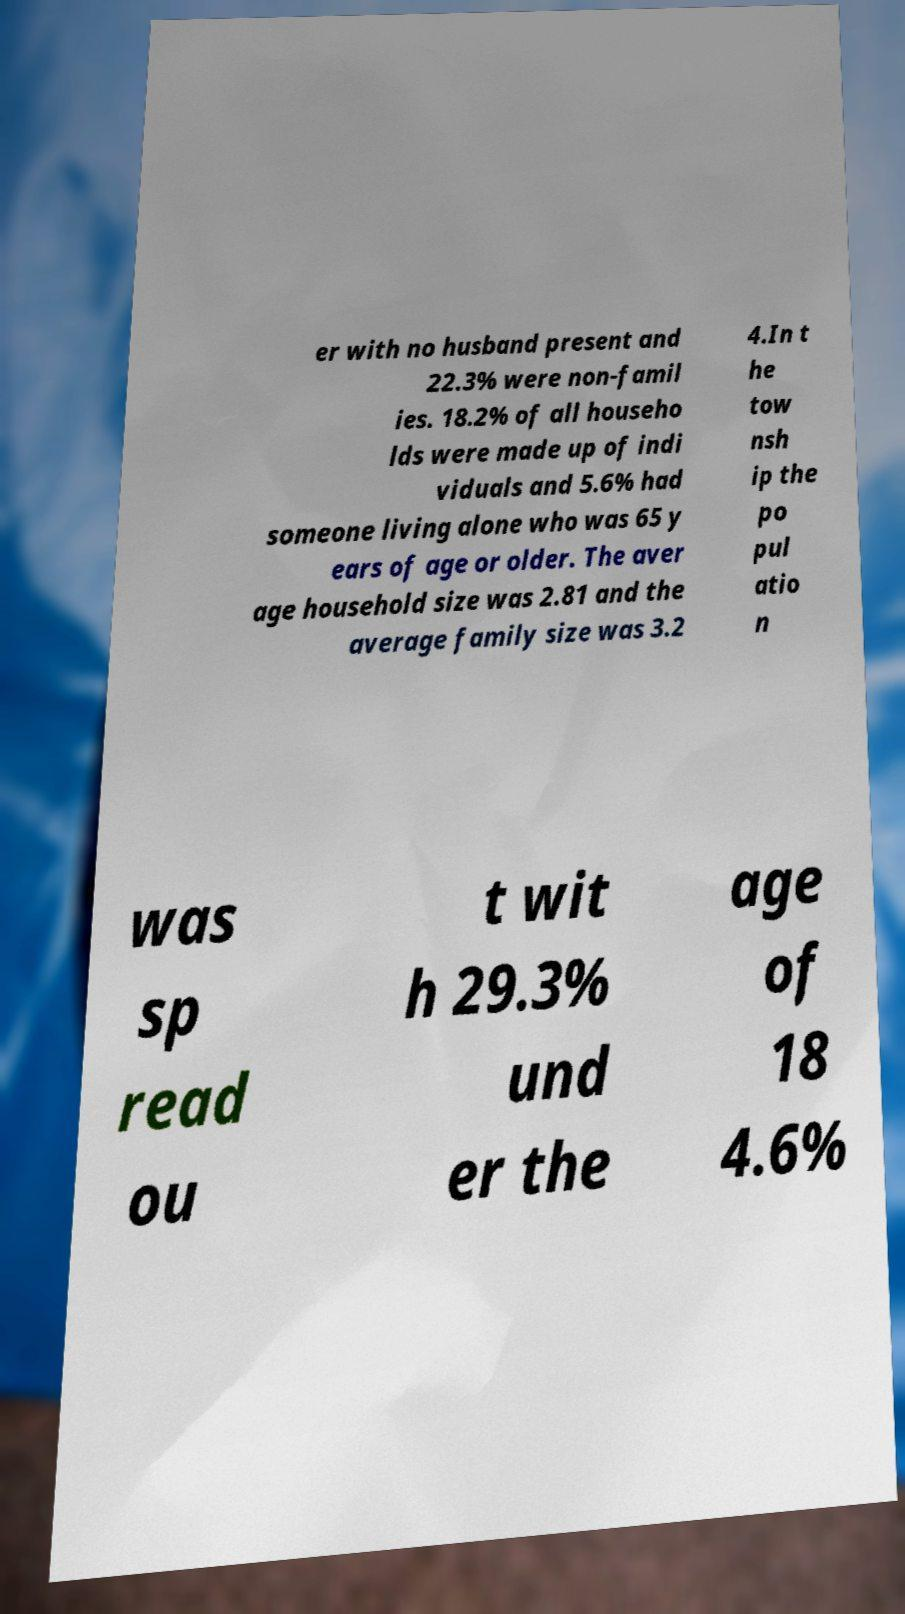Please identify and transcribe the text found in this image. er with no husband present and 22.3% were non-famil ies. 18.2% of all househo lds were made up of indi viduals and 5.6% had someone living alone who was 65 y ears of age or older. The aver age household size was 2.81 and the average family size was 3.2 4.In t he tow nsh ip the po pul atio n was sp read ou t wit h 29.3% und er the age of 18 4.6% 